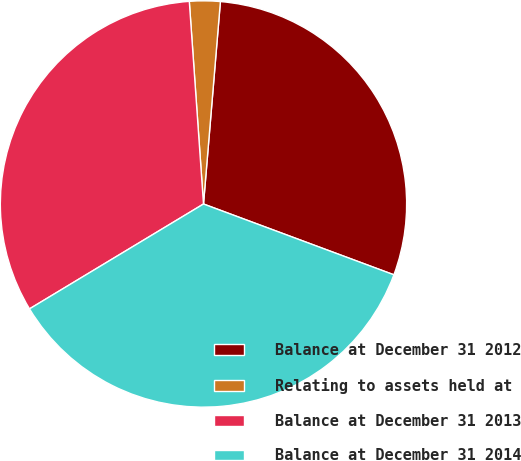Convert chart. <chart><loc_0><loc_0><loc_500><loc_500><pie_chart><fcel>Balance at December 31 2012<fcel>Relating to assets held at<fcel>Balance at December 31 2013<fcel>Balance at December 31 2014<nl><fcel>29.34%<fcel>2.44%<fcel>32.52%<fcel>35.7%<nl></chart> 